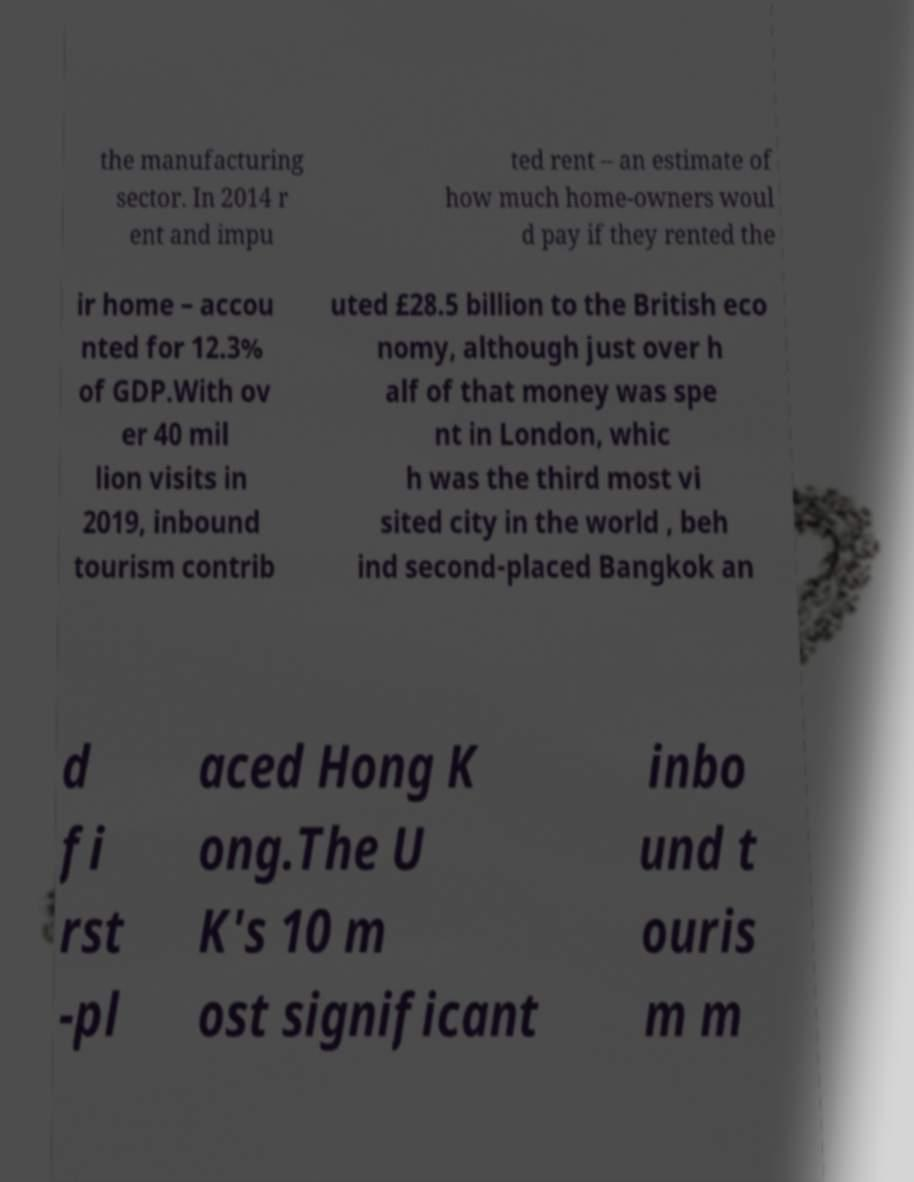Please identify and transcribe the text found in this image. the manufacturing sector. In 2014 r ent and impu ted rent – an estimate of how much home-owners woul d pay if they rented the ir home – accou nted for 12.3% of GDP.With ov er 40 mil lion visits in 2019, inbound tourism contrib uted £28.5 billion to the British eco nomy, although just over h alf of that money was spe nt in London, whic h was the third most vi sited city in the world , beh ind second-placed Bangkok an d fi rst -pl aced Hong K ong.The U K's 10 m ost significant inbo und t ouris m m 